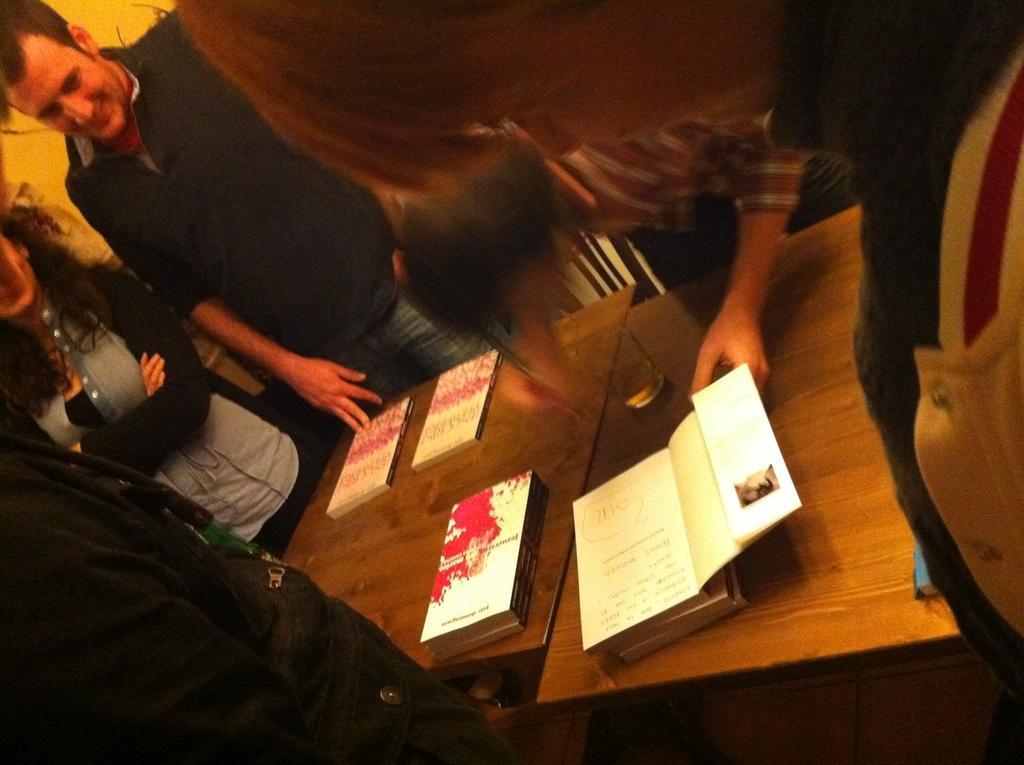How would you summarize this image in a sentence or two? These persons are standing, in-between of this person's there is a table, on this table there are books and glass. 